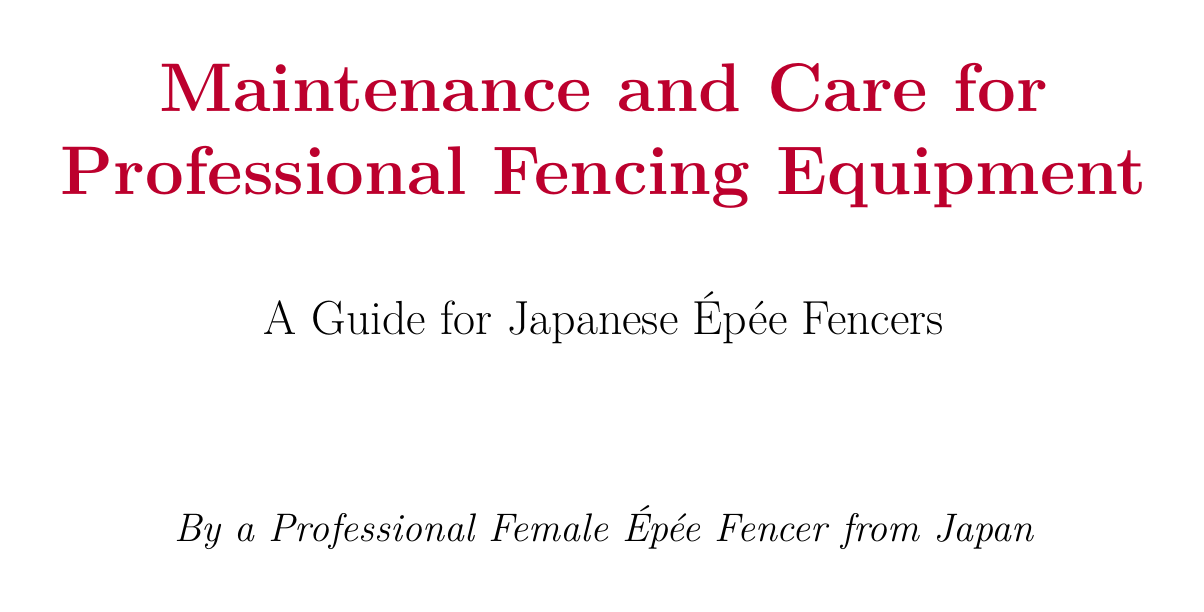what is the main purpose of the manual? The manual's purpose is to guide proper maintenance of fencing equipment for optimal performance and longevity.
Answer: guide proper maintenance what type of cord should be kept as spare? The document specifies keeping Allstar or PBT body cords in your fencing bag for emergencies.
Answer: Allstar or PBT how often should shoes be replaced? The manual advises replacing shoes every 6-12 months or when the soles show significant wear.
Answer: every 6-12 months which brand of épée points should be used for replacement? Worn-out tips should be replaced with Uhlmann or Negrini épée points.
Answer: Uhlmann or Negrini what is the suggested way to dry the fencing uniform? The document recommends air drying the uniform away from direct sunlight to prevent fabric weakening.
Answer: air dry away from direct sunlight what is the recommended method for maintaining the épée blade? Regular cleaning with a soft cloth and applying a thin layer of WD-40 are recommended for the épée blade.
Answer: clean with a soft cloth and WD-40 what should be done with tears or loose seams in the uniform? The manual suggests addressing any tears or loose seams immediately using specific repair services or basic sewing skills.
Answer: address immediately how often should the mask's interior be cleaned? It is recommended to clean the mask's interior with antibacterial wipes after each use.
Answer: after each use what type of cases should be used for traveling with fencing equipment? Proper cases like those from Linea or Leon Paul should be used to protect gear during transit.
Answer: Linea or Leon Paul 